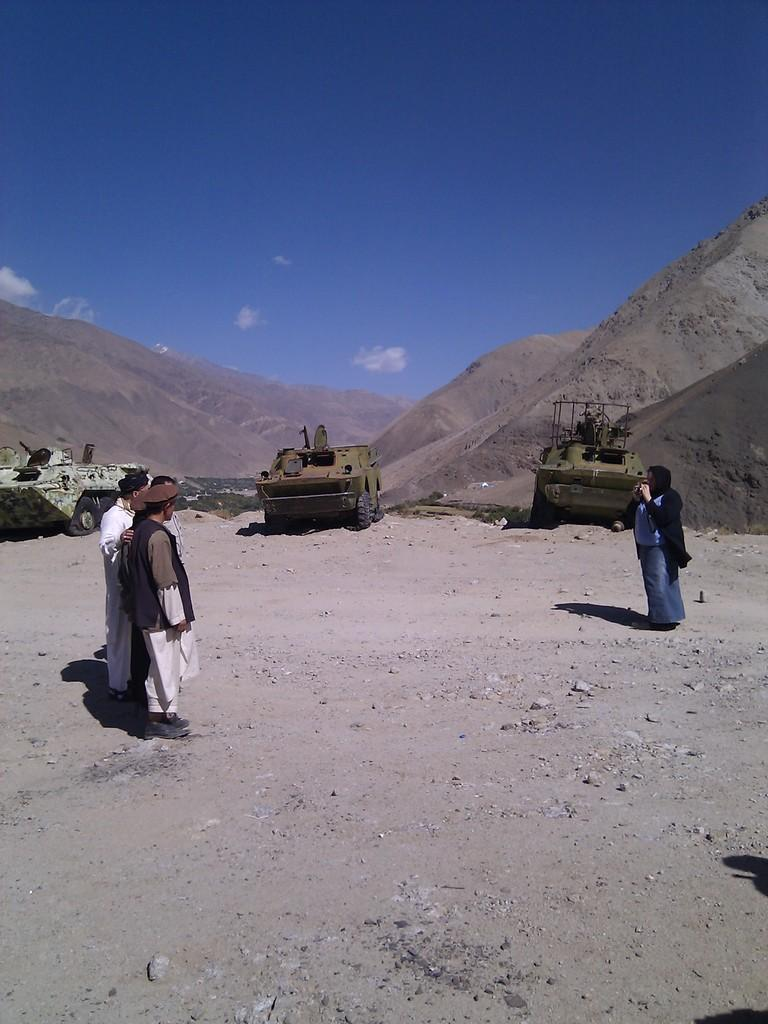What is happening in the image? There are people standing in the image. What can be seen in the distance behind the people? There are vehicles and mountains visible in the background. How would you describe the sky in the image? The sky is blue and white in color. What type of leg is visible on the people in the image? There is no specific leg mentioned or visible in the image; people generally have two legs. Is there an army present in the image? There is no mention of an army or any military presence in the image. 